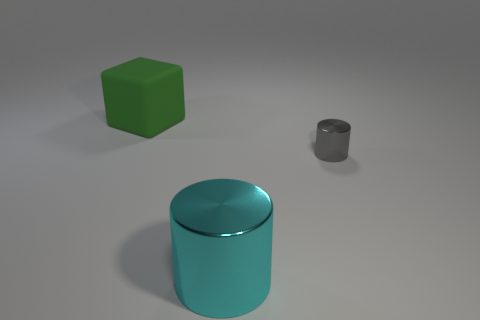Is there a small gray metallic object to the right of the object behind the tiny gray cylinder?
Your response must be concise. Yes. What is the color of the big thing right of the big green cube?
Ensure brevity in your answer.  Cyan. Are there an equal number of large green matte objects that are right of the cyan metal cylinder and large green matte things?
Provide a short and direct response. No. What is the shape of the thing that is on the right side of the green matte object and on the left side of the tiny gray metal object?
Keep it short and to the point. Cylinder. There is a small metallic thing that is the same shape as the large cyan thing; what is its color?
Offer a terse response. Gray. What shape is the large object in front of the cylinder that is behind the big object that is right of the green cube?
Provide a succinct answer. Cylinder. Do the metal cylinder that is in front of the tiny cylinder and the cylinder behind the big cylinder have the same size?
Make the answer very short. No. What number of large cubes are the same material as the cyan cylinder?
Your answer should be compact. 0. There is a shiny thing behind the large object that is in front of the big green matte object; how many cyan things are in front of it?
Provide a succinct answer. 1. Is the tiny gray metal object the same shape as the green matte object?
Ensure brevity in your answer.  No. 